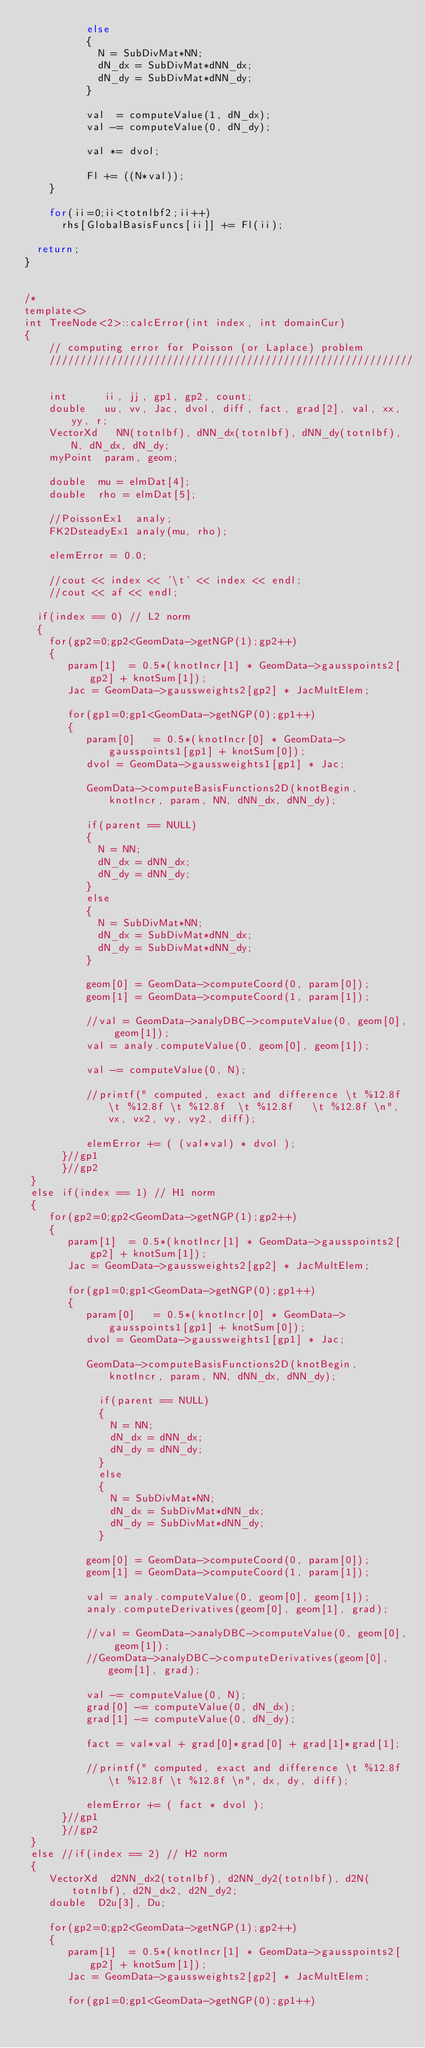<code> <loc_0><loc_0><loc_500><loc_500><_C++_>          else
          {
            N = SubDivMat*NN;
            dN_dx = SubDivMat*dNN_dx;
            dN_dy = SubDivMat*dNN_dy;
          }
          
          val  = computeValue(1, dN_dx);
          val -= computeValue(0, dN_dy);
          
          val *= dvol;
          
          Fl += ((N*val));
    }

    for(ii=0;ii<totnlbf2;ii++)
      rhs[GlobalBasisFuncs[ii]] += Fl(ii);

  return;
}


/*
template<>
int TreeNode<2>::calcError(int index, int domainCur)
{
    // computing error for Poisson (or Laplace) problem
    ///////////////////////////////////////////////////////////
    
    int      ii, jj, gp1, gp2, count;
    double   uu, vv, Jac, dvol, diff, fact, grad[2], val, xx, yy, r;
    VectorXd   NN(totnlbf), dNN_dx(totnlbf), dNN_dy(totnlbf), N, dN_dx, dN_dy;
    myPoint  param, geom;

    double  mu = elmDat[4];
    double  rho = elmDat[5];

    //PoissonEx1  analy;
    FK2DsteadyEx1 analy(mu, rho);

    elemError = 0.0;

    //cout << index << '\t' << index << endl;
    //cout << af << endl;

  if(index == 0) // L2 norm
  {
    for(gp2=0;gp2<GeomData->getNGP(1);gp2++)
    {
       param[1]  = 0.5*(knotIncr[1] * GeomData->gausspoints2[gp2] + knotSum[1]);
       Jac = GeomData->gaussweights2[gp2] * JacMultElem;
       
       for(gp1=0;gp1<GeomData->getNGP(0);gp1++)
       {
          param[0]   = 0.5*(knotIncr[0] * GeomData->gausspoints1[gp1] + knotSum[0]);
          dvol = GeomData->gaussweights1[gp1] * Jac;

          GeomData->computeBasisFunctions2D(knotBegin, knotIncr, param, NN, dNN_dx, dNN_dy);

          if(parent == NULL)
          {
            N = NN;
            dN_dx = dNN_dx;
            dN_dy = dNN_dy;
          }
          else
          {
            N = SubDivMat*NN;
            dN_dx = SubDivMat*dNN_dx;
            dN_dy = SubDivMat*dNN_dy;
          }

          geom[0] = GeomData->computeCoord(0, param[0]);
          geom[1] = GeomData->computeCoord(1, param[1]);

          //val = GeomData->analyDBC->computeValue(0, geom[0], geom[1]);
          val = analy.computeValue(0, geom[0], geom[1]);

          val -= computeValue(0, N);

          //printf(" computed, exact and difference \t %12.8f \t %12.8f \t %12.8f  \t %12.8f   \t %12.8f \n", vx, vx2, vy, vy2, diff);
          
          elemError += ( (val*val) * dvol );
      }//gp1
      }//gp2
 }
 else if(index == 1) // H1 norm
 {
    for(gp2=0;gp2<GeomData->getNGP(1);gp2++)
    {
       param[1]  = 0.5*(knotIncr[1] * GeomData->gausspoints2[gp2] + knotSum[1]);
       Jac = GeomData->gaussweights2[gp2] * JacMultElem;
       
       for(gp1=0;gp1<GeomData->getNGP(0);gp1++)
       {
          param[0]   = 0.5*(knotIncr[0] * GeomData->gausspoints1[gp1] + knotSum[0]);
          dvol = GeomData->gaussweights1[gp1] * Jac;

          GeomData->computeBasisFunctions2D(knotBegin, knotIncr, param, NN, dNN_dx, dNN_dy);

            if(parent == NULL)
            {
              N = NN;
              dN_dx = dNN_dx;
              dN_dy = dNN_dy;
            }
            else
            {
              N = SubDivMat*NN;
              dN_dx = SubDivMat*dNN_dx;
              dN_dy = SubDivMat*dNN_dy;
            }

          geom[0] = GeomData->computeCoord(0, param[0]);
          geom[1] = GeomData->computeCoord(1, param[1]);

          val = analy.computeValue(0, geom[0], geom[1]);
          analy.computeDerivatives(geom[0], geom[1], grad);

          //val = GeomData->analyDBC->computeValue(0, geom[0], geom[1]);
          //GeomData->analyDBC->computeDerivatives(geom[0], geom[1], grad);

          val -= computeValue(0, N);
          grad[0] -= computeValue(0, dN_dx);
          grad[1] -= computeValue(0, dN_dy);

          fact = val*val + grad[0]*grad[0] + grad[1]*grad[1];

          //printf(" computed, exact and difference \t %12.8f \t %12.8f \t %12.8f \n", dx, dy, diff);
        
          elemError += ( fact * dvol );
      }//gp1
      }//gp2
 }
 else //if(index == 2) // H2 norm
 {
    VectorXd  d2NN_dx2(totnlbf), d2NN_dy2(totnlbf), d2N(totnlbf), d2N_dx2, d2N_dy2;
    double  D2u[3], Du;

    for(gp2=0;gp2<GeomData->getNGP(1);gp2++)
    {
       param[1]  = 0.5*(knotIncr[1] * GeomData->gausspoints2[gp2] + knotSum[1]);
       Jac = GeomData->gaussweights2[gp2] * JacMultElem;
       
       for(gp1=0;gp1<GeomData->getNGP(0);gp1++)</code> 